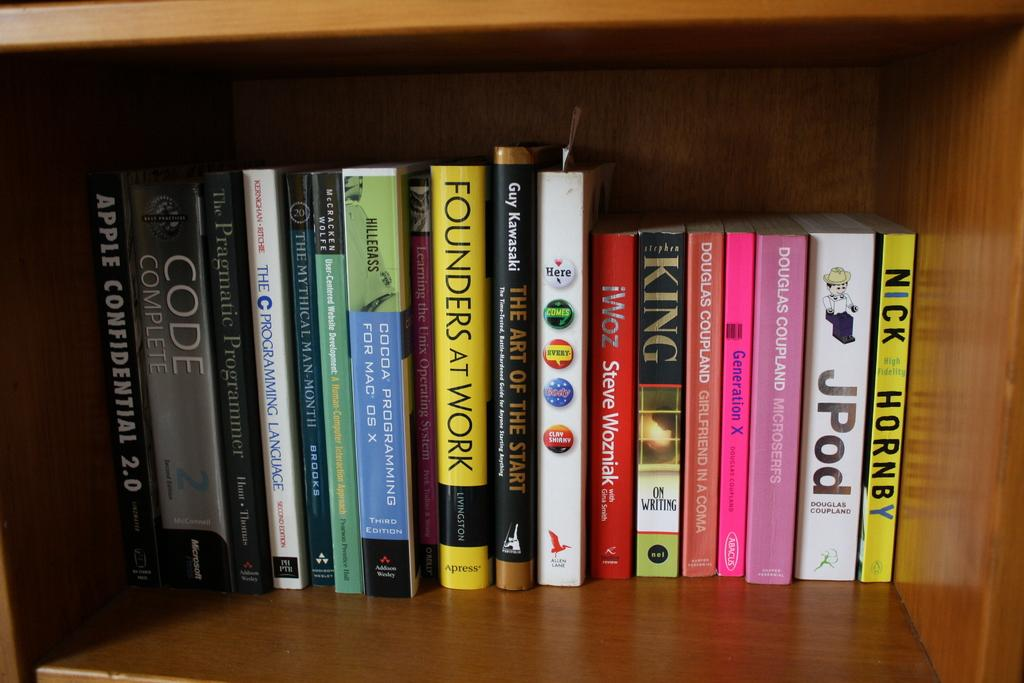<image>
Present a compact description of the photo's key features. A book is titled Founders at work and is on a shelf with other books. 